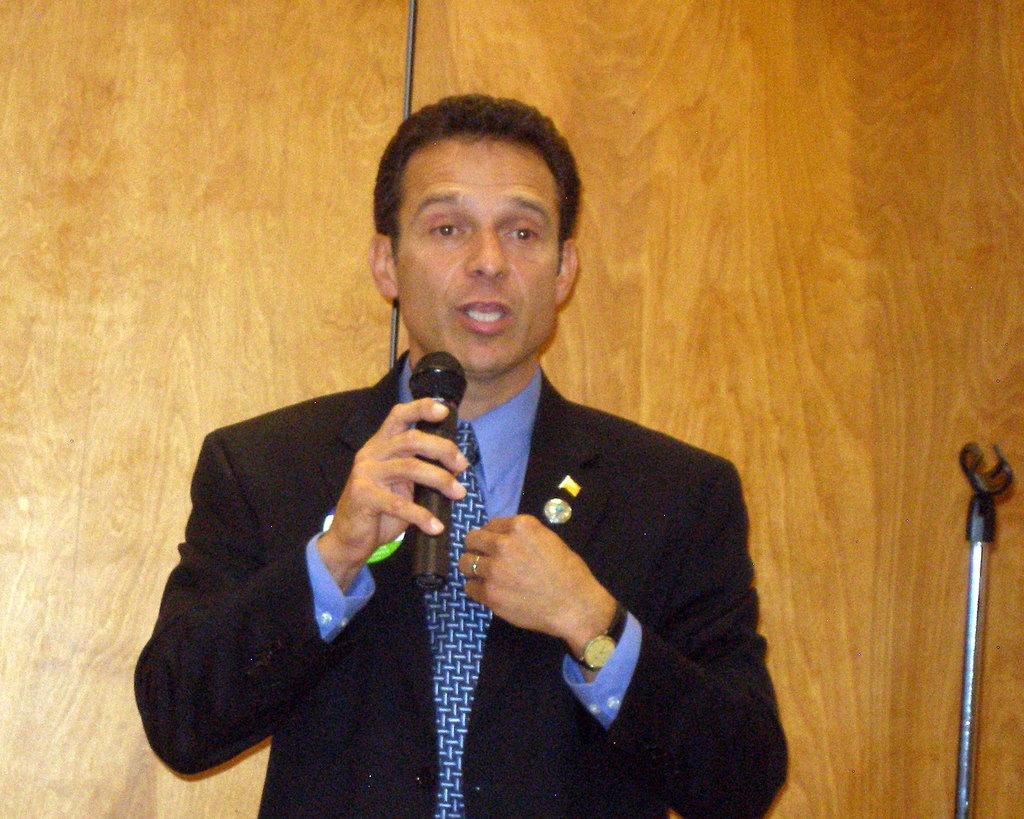Please provide a concise description of this image. Here in this image I can see a man holding a mic in his right hand. I can see he is wearing a black color of dress with blue color of tie and I can see a watch in his left hand. 